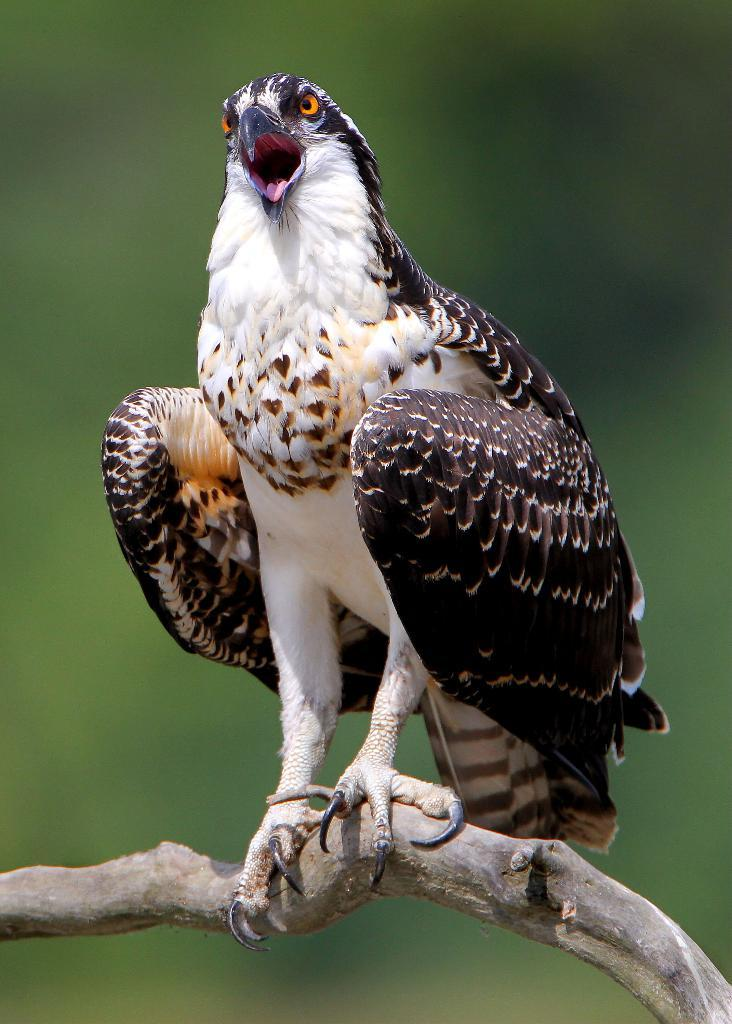What is the main subject in the foreground of the image? There is a bird in the foreground of the image. Where is the bird located? The bird is on a stem. What can be observed about the background of the image? The background of the image is blurred. What type of pump is being used by the bird in the image? There is no pump present in the image; the bird is simply on a stem. 